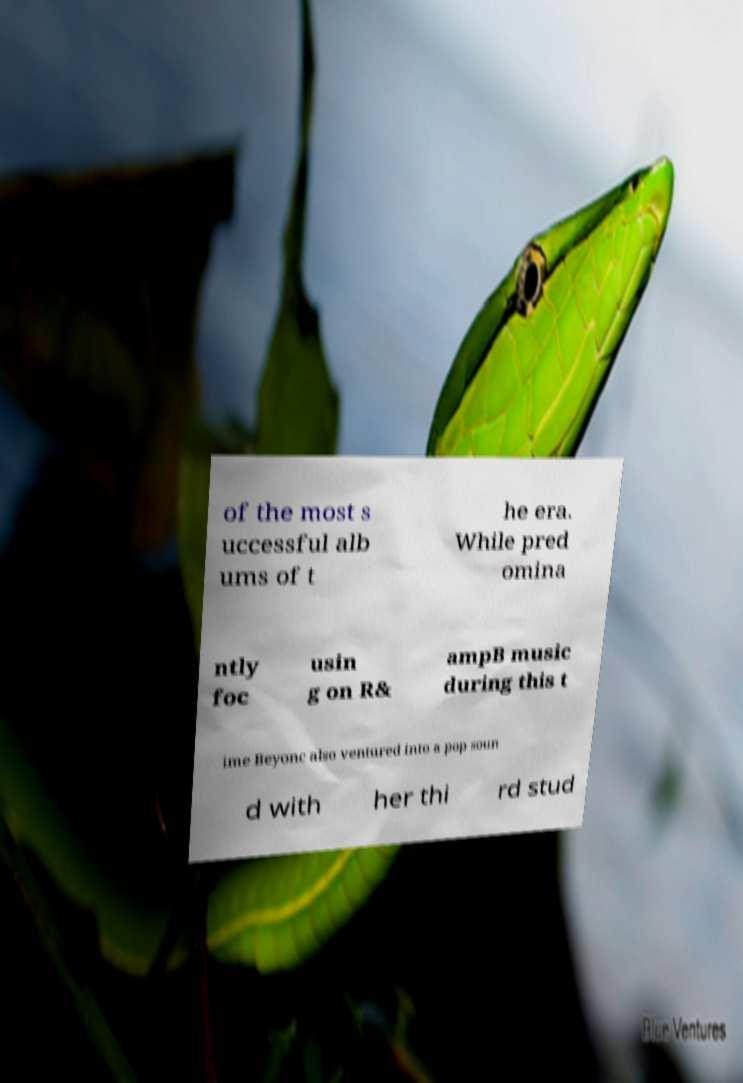Can you read and provide the text displayed in the image?This photo seems to have some interesting text. Can you extract and type it out for me? of the most s uccessful alb ums of t he era. While pred omina ntly foc usin g on R& ampB music during this t ime Beyonc also ventured into a pop soun d with her thi rd stud 